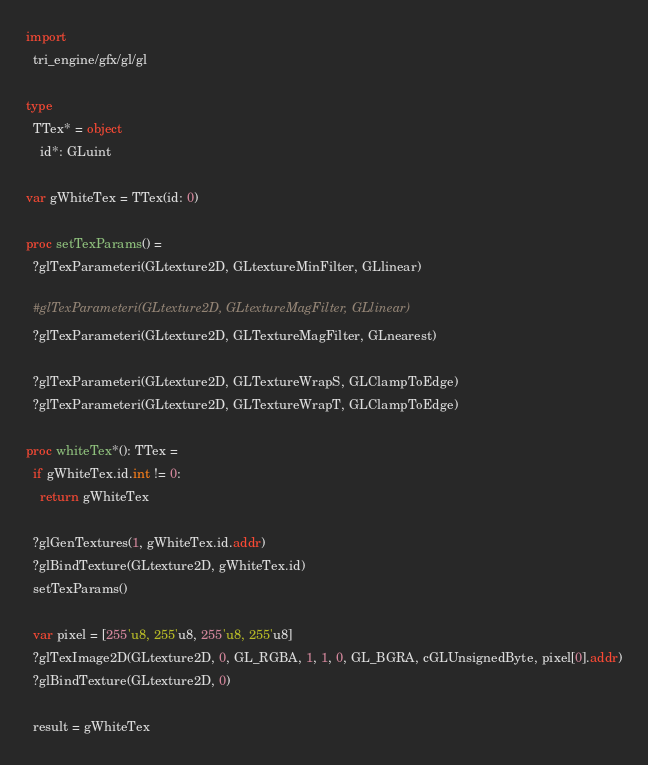<code> <loc_0><loc_0><loc_500><loc_500><_Nim_>import
  tri_engine/gfx/gl/gl

type
  TTex* = object
    id*: GLuint

var gWhiteTex = TTex(id: 0)

proc setTexParams() =
  ?glTexParameteri(GLtexture2D, GLtextureMinFilter, GLlinear)

  #glTexParameteri(GLtexture2D, GLtextureMagFilter, GLlinear)
  ?glTexParameteri(GLtexture2D, GLTextureMagFilter, GLnearest)

  ?glTexParameteri(GLtexture2D, GLTextureWrapS, GLClampToEdge)
  ?glTexParameteri(GLtexture2D, GLTextureWrapT, GLClampToEdge)

proc whiteTex*(): TTex =
  if gWhiteTex.id.int != 0:
    return gWhiteTex

  ?glGenTextures(1, gWhiteTex.id.addr)
  ?glBindTexture(GLtexture2D, gWhiteTex.id)
  setTexParams()

  var pixel = [255'u8, 255'u8, 255'u8, 255'u8]
  ?glTexImage2D(GLtexture2D, 0, GL_RGBA, 1, 1, 0, GL_BGRA, cGLUnsignedByte, pixel[0].addr)
  ?glBindTexture(GLtexture2D, 0)

  result = gWhiteTex
</code> 